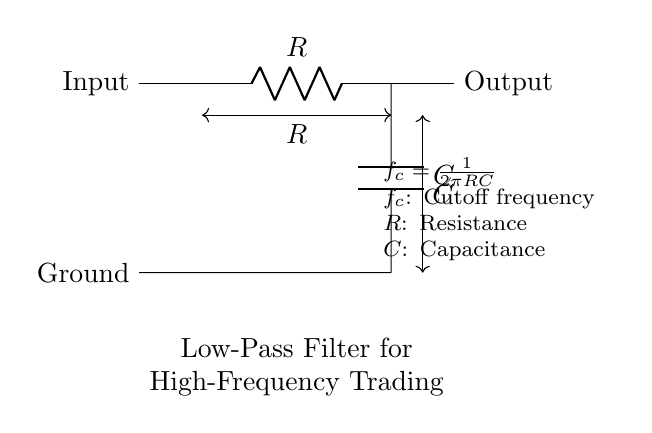What is the main function of this circuit? The circuit is a low-pass filter which allows low-frequency signals to pass while attenuating high-frequency noise. This is beneficial in high-frequency trading for improving communication clarity.
Answer: Low-pass filter What is the symbol for resistance in this circuit? The resistance in the circuit is represented by the letter "R" next to the resistor component. This is a common notation in circuit diagrams to denote resistance.
Answer: R What does the cutoff frequency formula indicate? The formula \( f_c = \frac{1}{2\pi RC} \) shows how the cutoff frequency is determined by the values of resistance and capacitance in the filter, thus affecting the filter's performance.
Answer: It indicates the relationship between resistance and capacitance What is the practical implication of increasing the resistance value? Increasing the resistance will lower the cutoff frequency, resulting in a more significant attenuation of higher frequencies, which is useful for reducing noise further but may also delay the response to desired signals.
Answer: Lower cutoff frequency How is the output connected in this circuit? The output is taken from the node where the resistor and capacitor connect, allowing the processed signal to exit the filter circuit while maintaining the connection to input and ground.
Answer: From the node between R and C What happens to signals above the cutoff frequency? Signals above the cutoff frequency are significantly attenuated or reduced, which helps minimize unwanted high-frequency noise in the communication system.
Answer: Attenuated What is the role of the capacitor in this circuit? The capacitor helps store charge and filter out high-frequency signals, allowing only low-frequency signals to appear at the output. This is vital for maintaining the integrity of communication in high-frequency trading.
Answer: Filter out high-frequency signals 